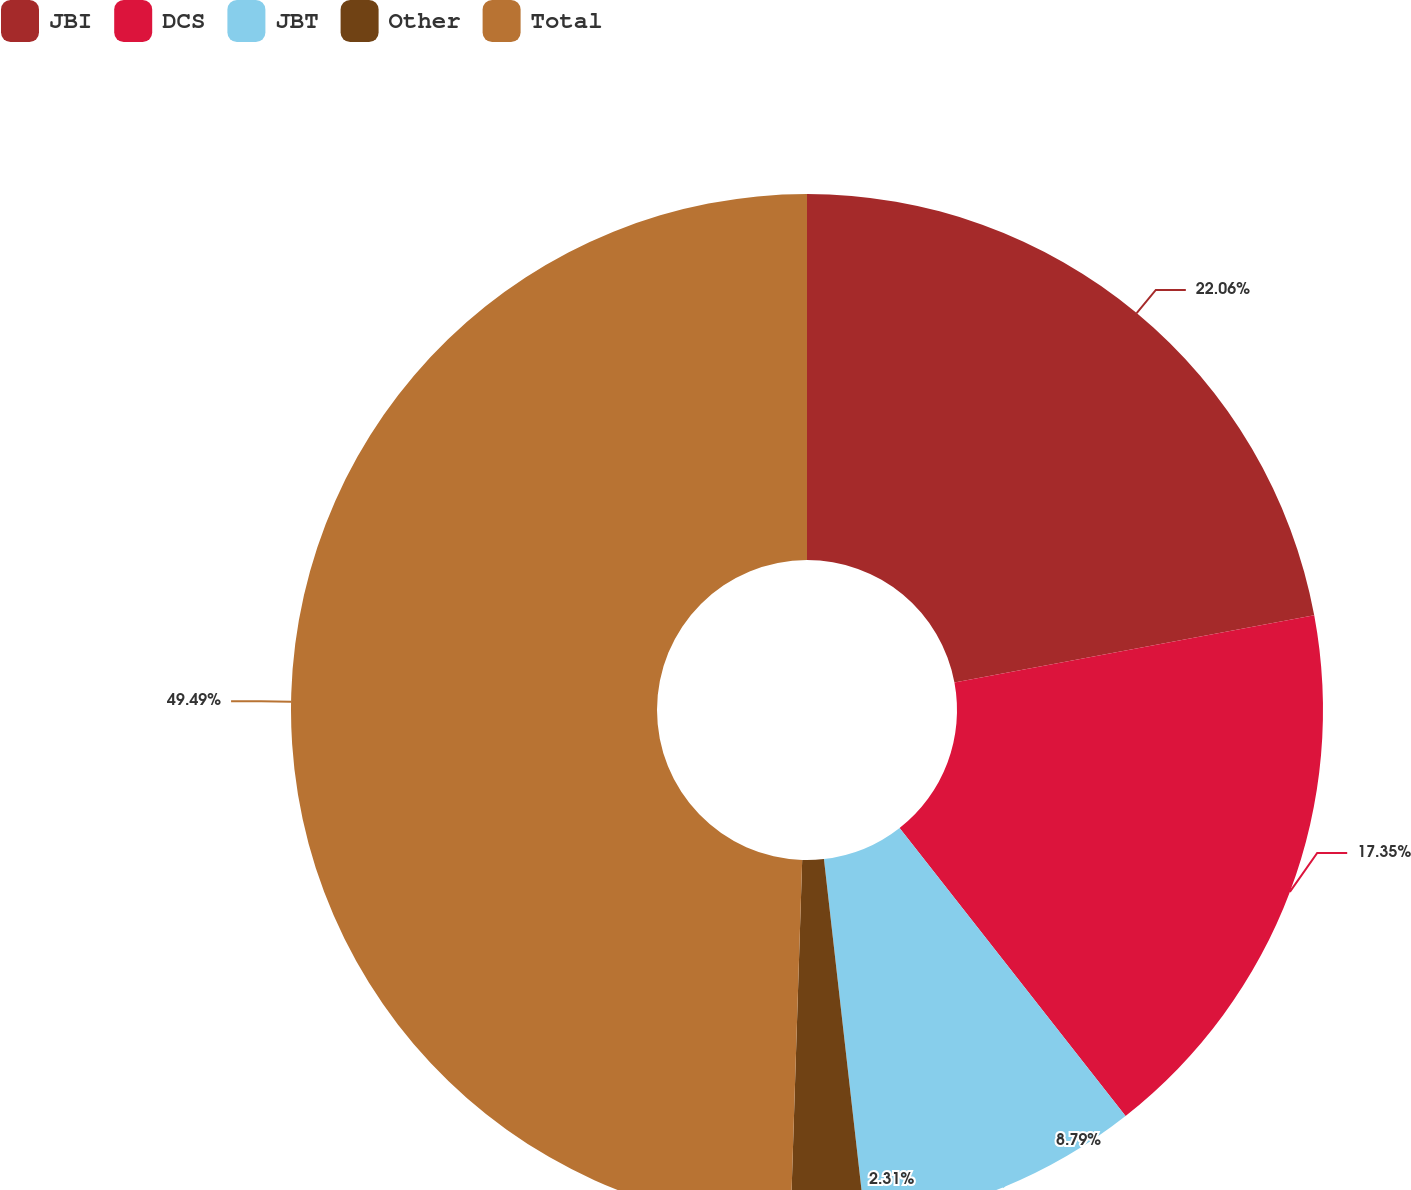Convert chart. <chart><loc_0><loc_0><loc_500><loc_500><pie_chart><fcel>JBI<fcel>DCS<fcel>JBT<fcel>Other<fcel>Total<nl><fcel>22.06%<fcel>17.35%<fcel>8.79%<fcel>2.31%<fcel>49.49%<nl></chart> 